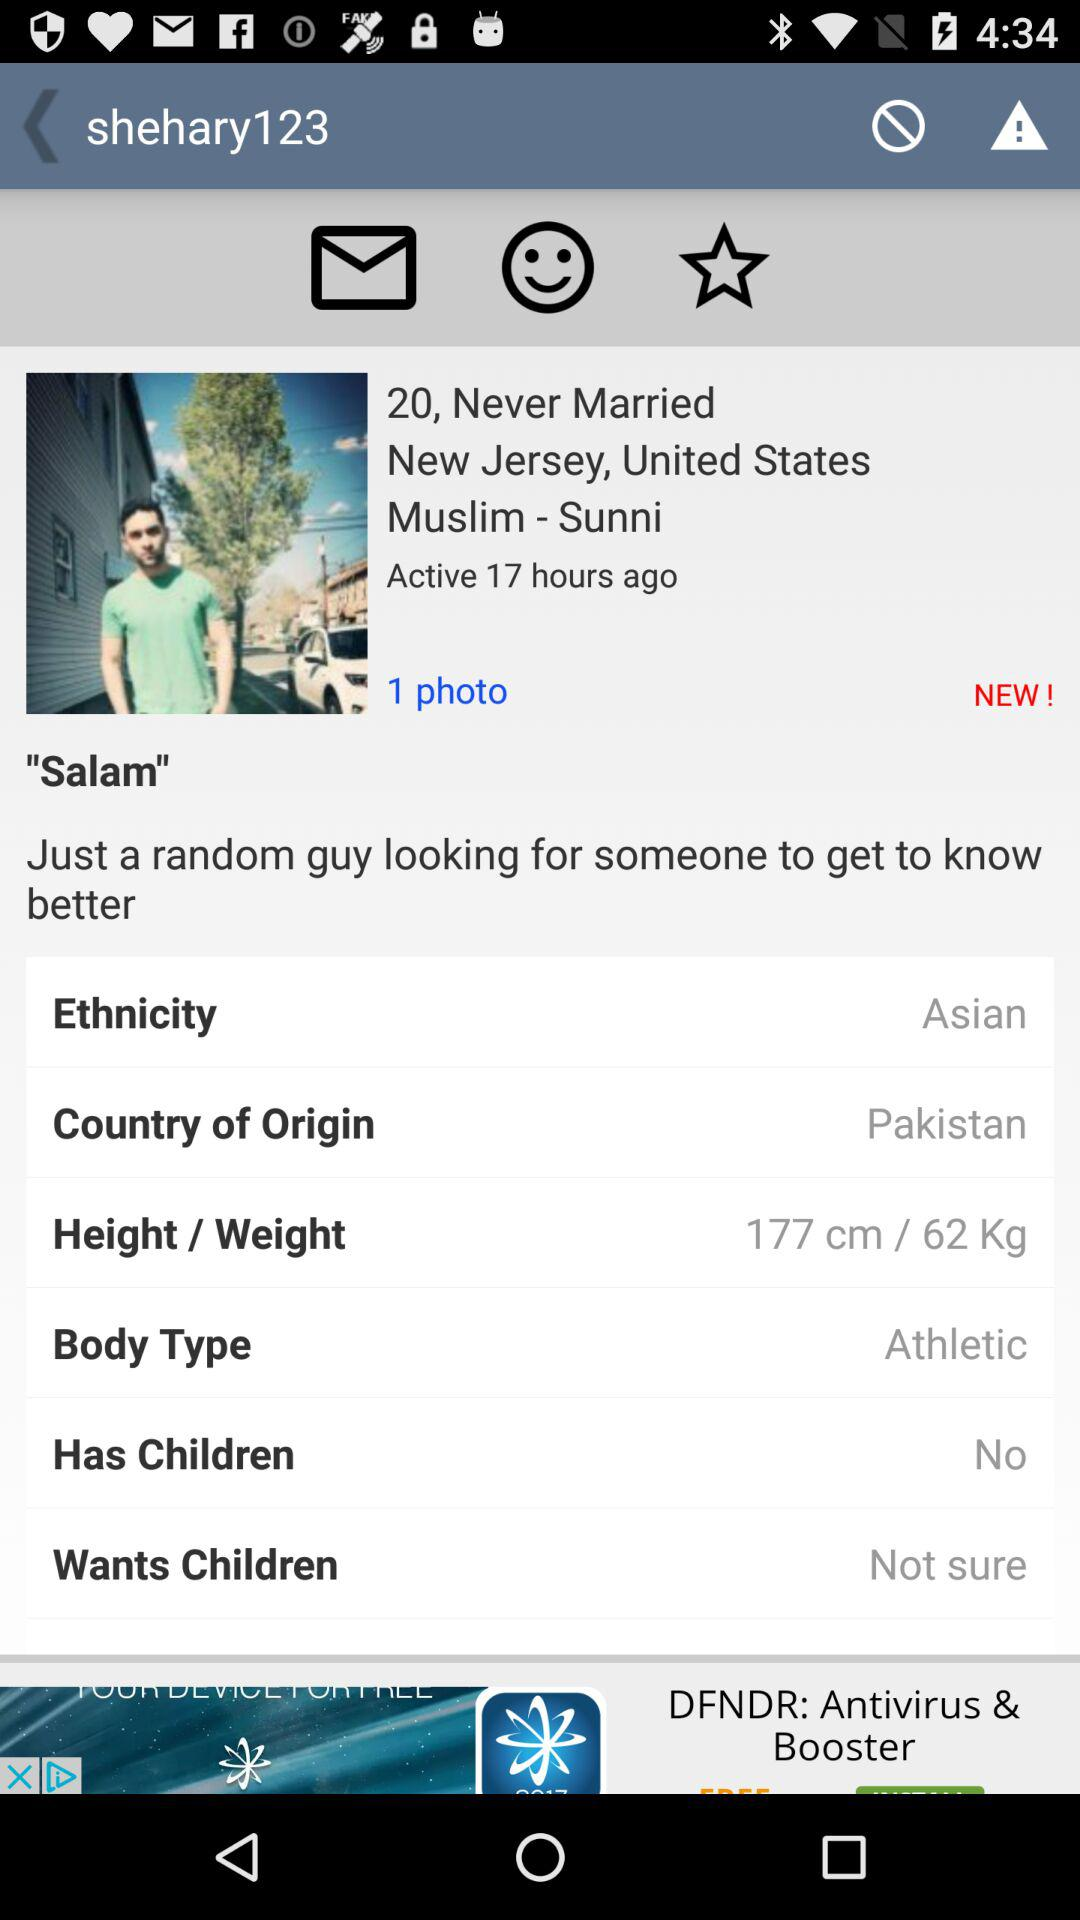What is the country of origin? The country of origin is Pakistan. 